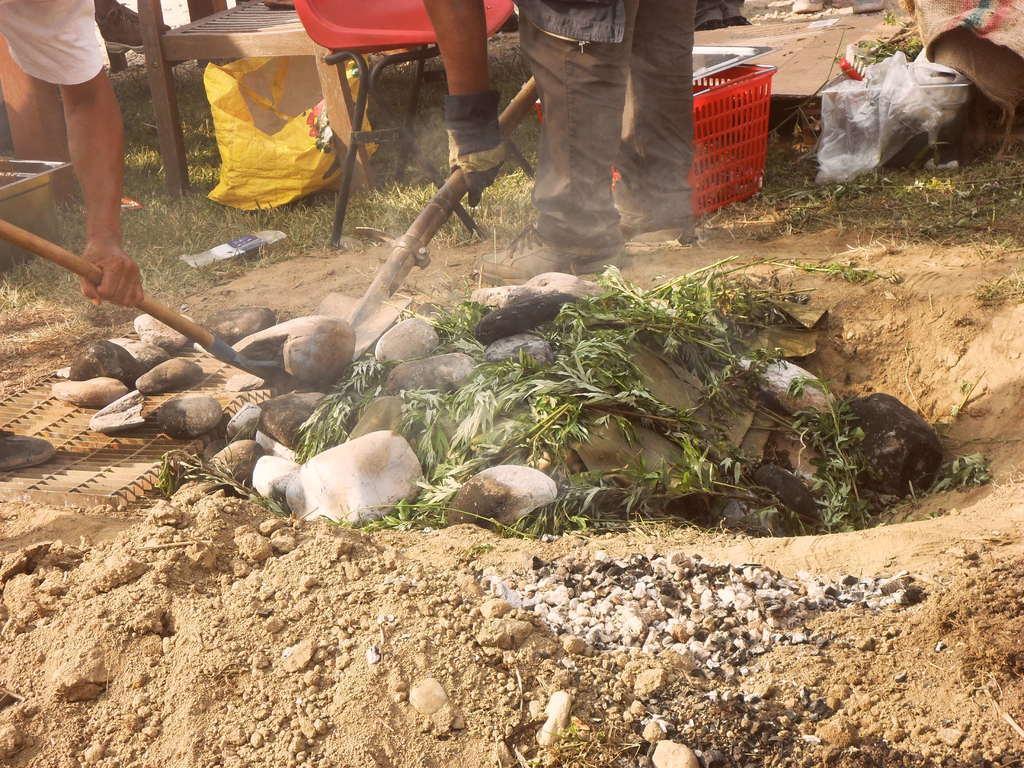Describe this image in one or two sentences. In this picture we can see two persons, they are holding tools, in front of them we can see few rocks, beside them we can find chairs, plastic covers, bowl and a basket. 